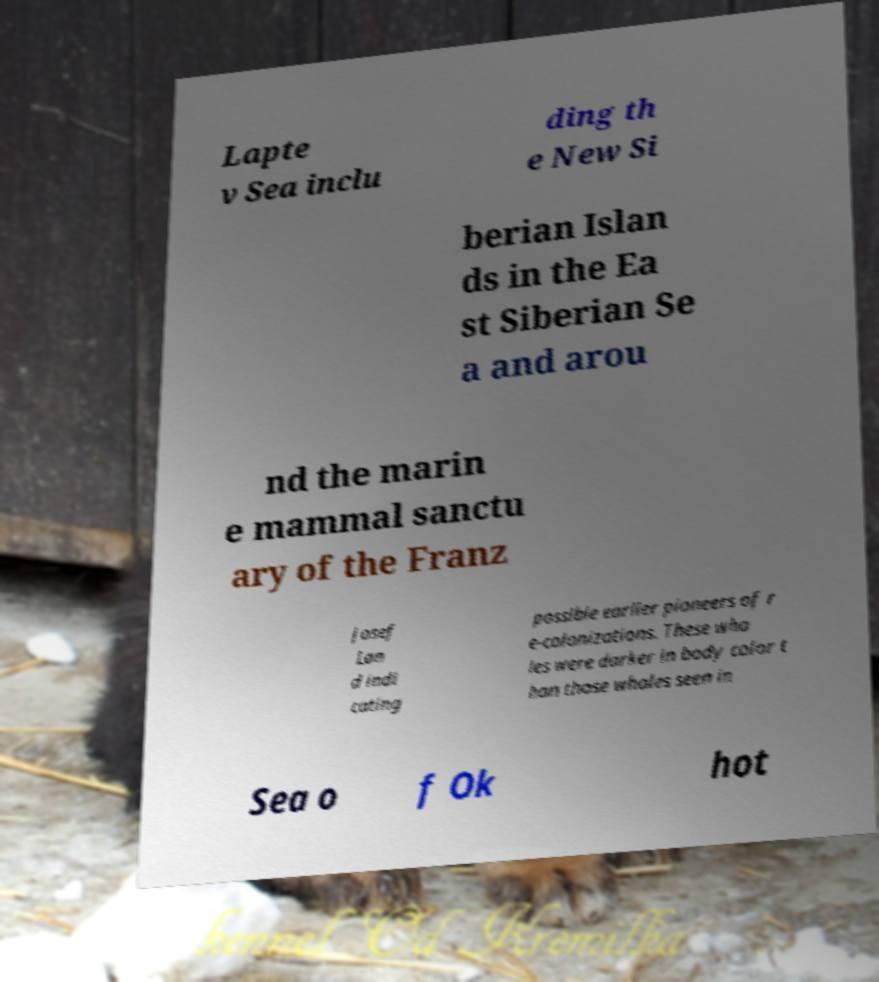Please identify and transcribe the text found in this image. Lapte v Sea inclu ding th e New Si berian Islan ds in the Ea st Siberian Se a and arou nd the marin e mammal sanctu ary of the Franz Josef Lan d indi cating possible earlier pioneers of r e-colonizations. These wha les were darker in body color t han those whales seen in Sea o f Ok hot 